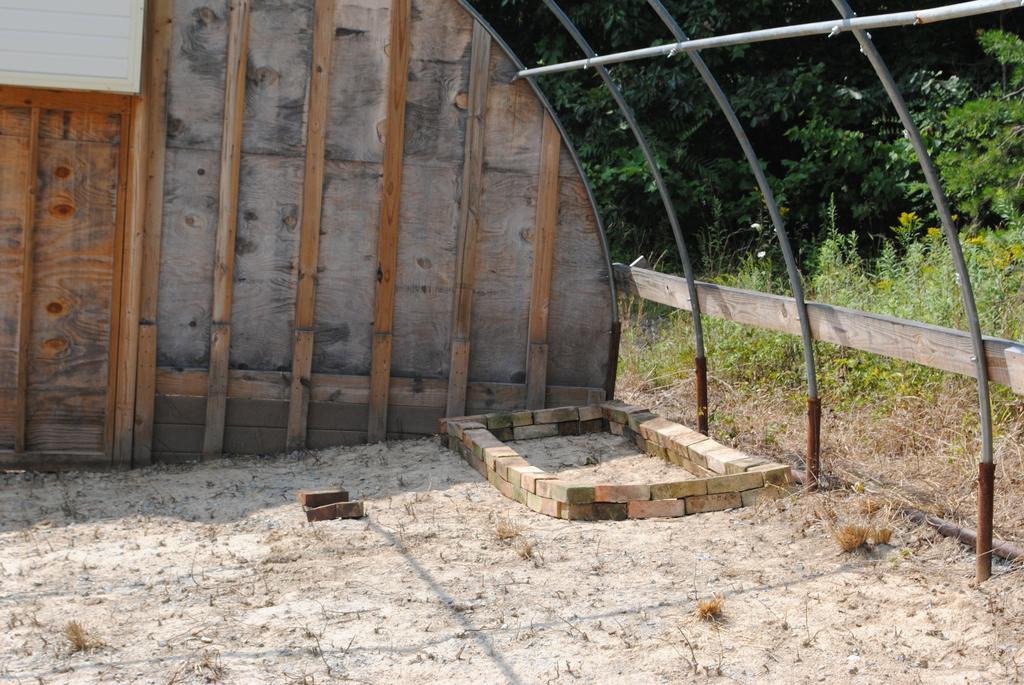Please provide a concise description of this image. In the picture we can see a wooden frame and near it, we can see some bricks are placed on the path and to the wooden frame we can see some iron rods which are shaped as a shed and behind it we can see plants, trees. 